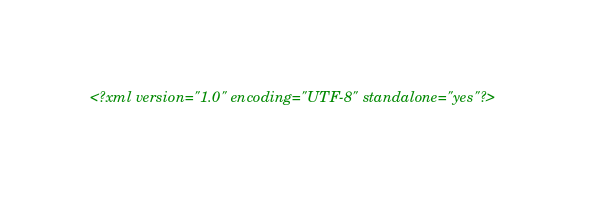<code> <loc_0><loc_0><loc_500><loc_500><_XML_><?xml version="1.0" encoding="UTF-8" standalone="yes"?></code> 